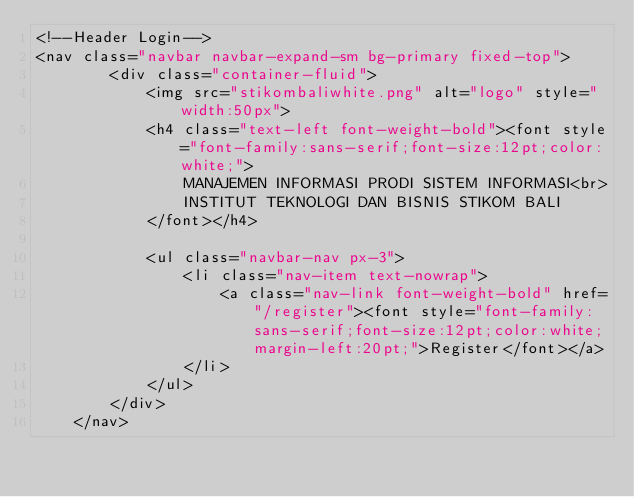<code> <loc_0><loc_0><loc_500><loc_500><_PHP_><!--Header Login-->
<nav class="navbar navbar-expand-sm bg-primary fixed-top">
        <div class="container-fluid">
            <img src="stikombaliwhite.png" alt="logo" style="width:50px">
            <h4 class="text-left font-weight-bold"><font style="font-family:sans-serif;font-size:12pt;color:white;">
                MANAJEMEN INFORMASI PRODI SISTEM INFORMASI<br>
                INSTITUT TEKNOLOGI DAN BISNIS STIKOM BALI
            </font></h4>
            
            <ul class="navbar-nav px-3">
                <li class="nav-item text-nowrap">
                    <a class="nav-link font-weight-bold" href="/register"><font style="font-family:sans-serif;font-size:12pt;color:white;margin-left:20pt;">Register</font></a>
                </li>
            </ul>
        </div>
    </nav></code> 